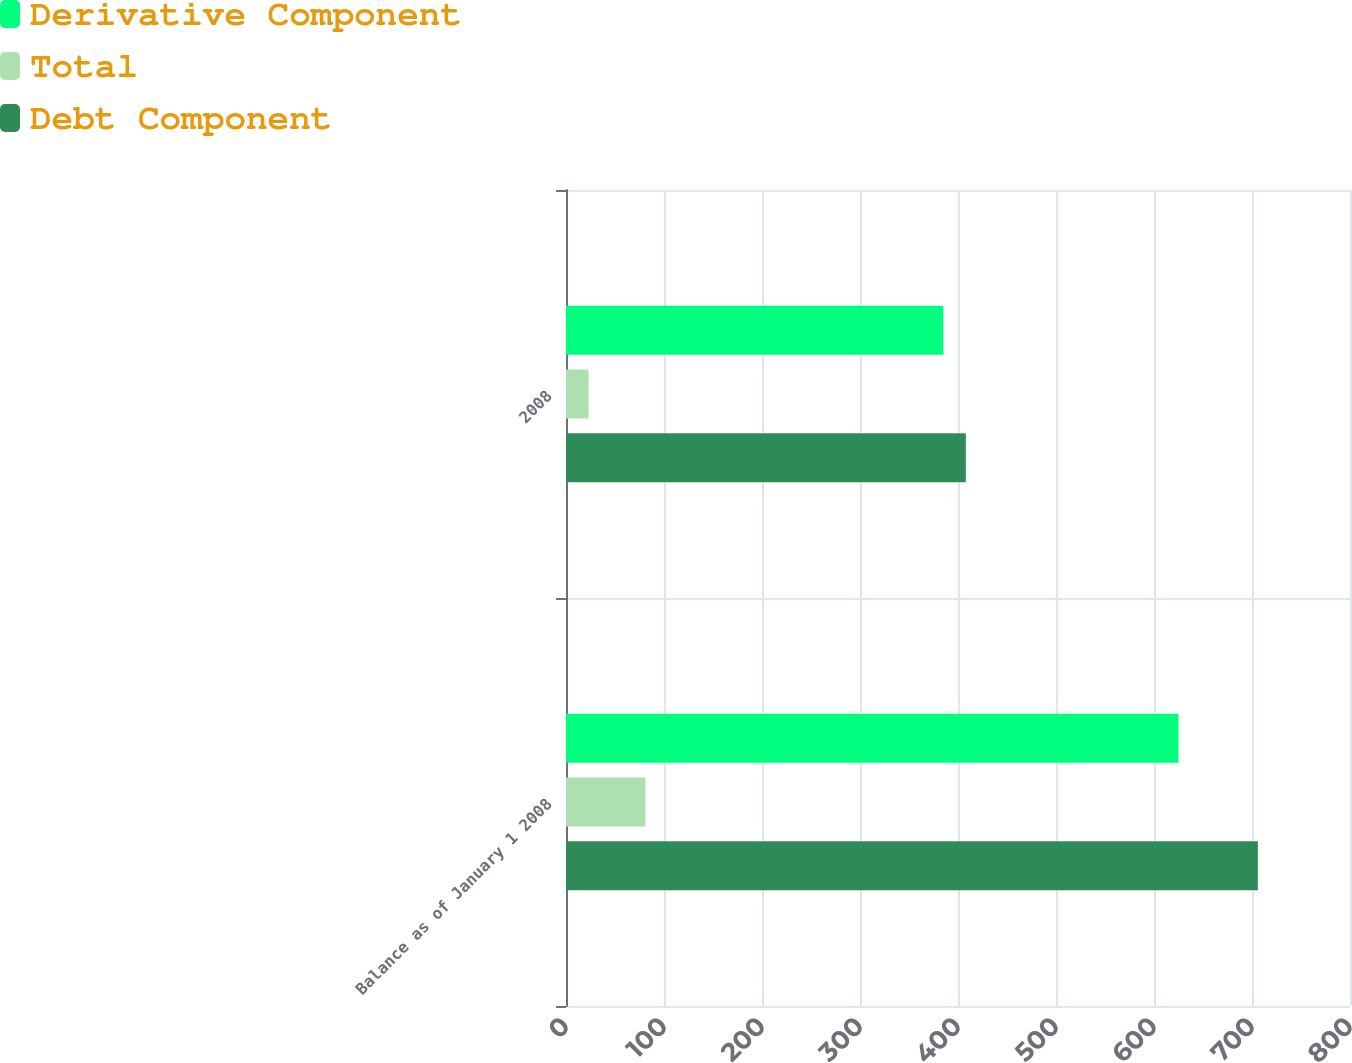Convert chart to OTSL. <chart><loc_0><loc_0><loc_500><loc_500><stacked_bar_chart><ecel><fcel>Balance as of January 1 2008<fcel>2008<nl><fcel>Derivative Component<fcel>625<fcel>385<nl><fcel>Total<fcel>81<fcel>23<nl><fcel>Debt Component<fcel>706<fcel>408<nl></chart> 